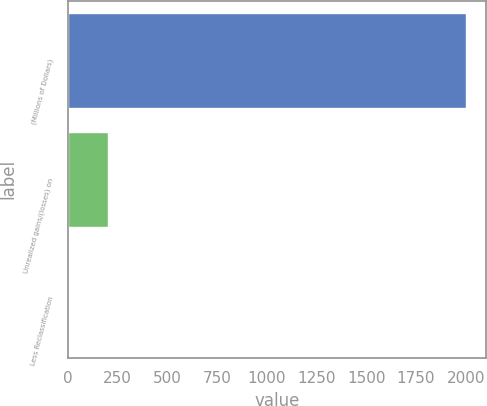<chart> <loc_0><loc_0><loc_500><loc_500><bar_chart><fcel>(Millions of Dollars)<fcel>Unrealized gains/(losses) on<fcel>Less Reclassification<nl><fcel>2002<fcel>203.8<fcel>4<nl></chart> 